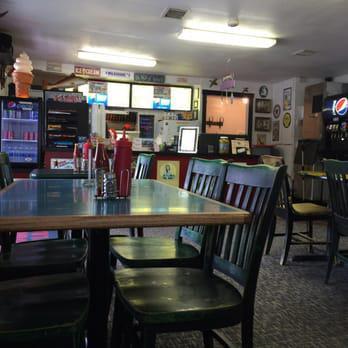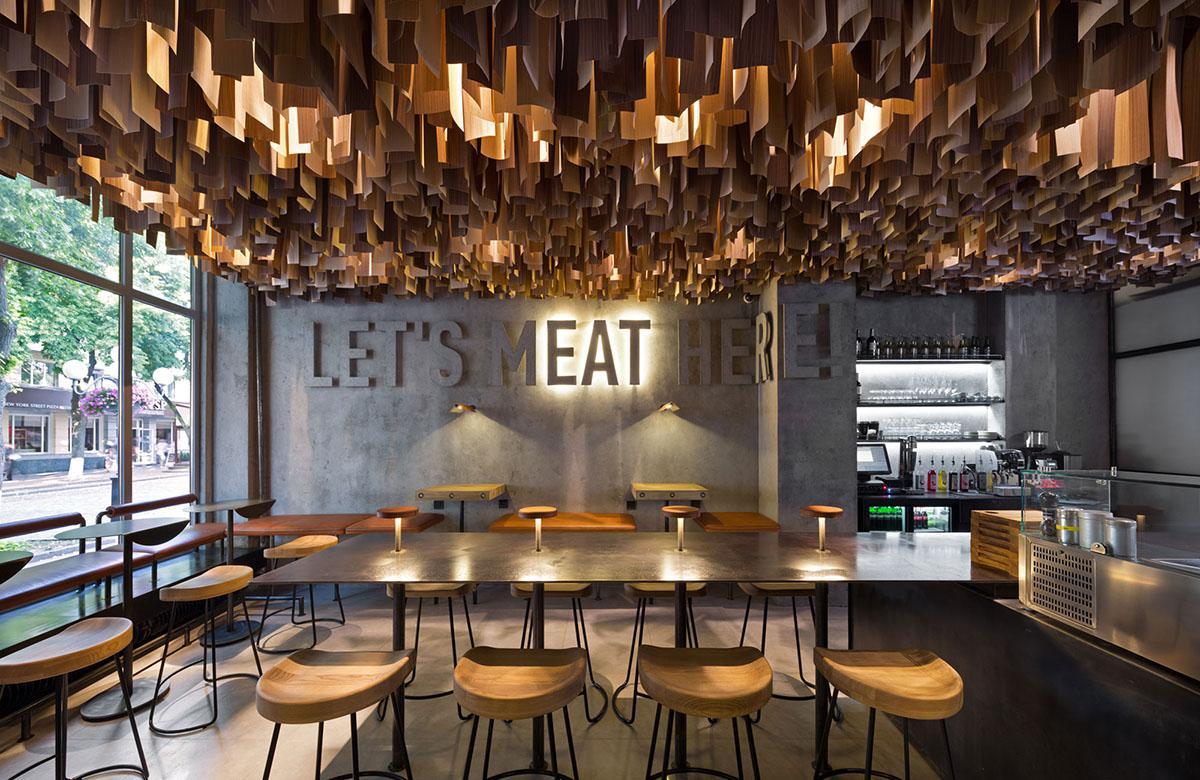The first image is the image on the left, the second image is the image on the right. Analyze the images presented: Is the assertion "There are two restaurants will all of its seats empty." valid? Answer yes or no. Yes. The first image is the image on the left, the second image is the image on the right. Considering the images on both sides, is "There are people in the right image but not in the left image." valid? Answer yes or no. No. 